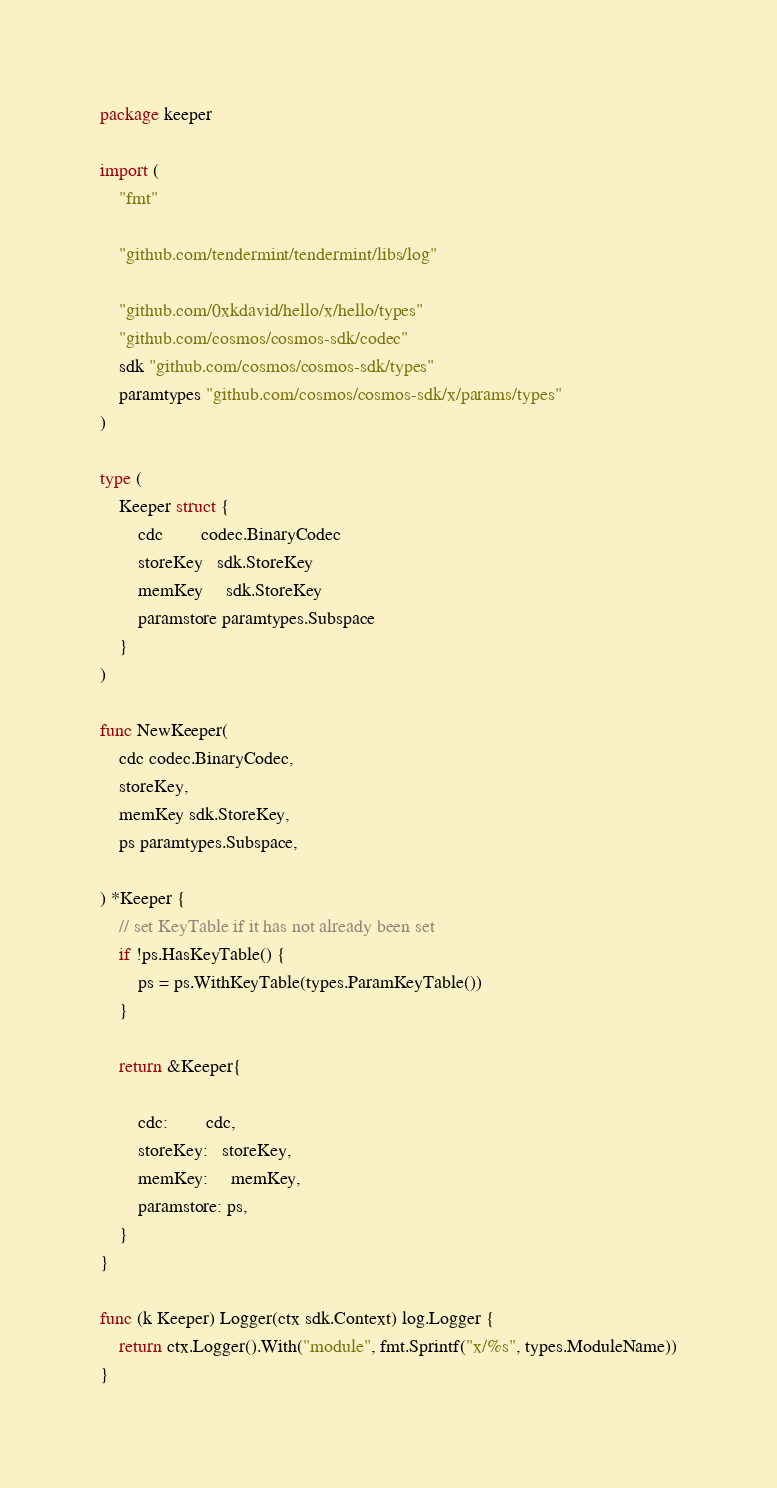Convert code to text. <code><loc_0><loc_0><loc_500><loc_500><_Go_>package keeper

import (
	"fmt"

	"github.com/tendermint/tendermint/libs/log"

	"github.com/0xkdavid/hello/x/hello/types"
	"github.com/cosmos/cosmos-sdk/codec"
	sdk "github.com/cosmos/cosmos-sdk/types"
	paramtypes "github.com/cosmos/cosmos-sdk/x/params/types"
)

type (
	Keeper struct {
		cdc        codec.BinaryCodec
		storeKey   sdk.StoreKey
		memKey     sdk.StoreKey
		paramstore paramtypes.Subspace
	}
)

func NewKeeper(
	cdc codec.BinaryCodec,
	storeKey,
	memKey sdk.StoreKey,
	ps paramtypes.Subspace,

) *Keeper {
	// set KeyTable if it has not already been set
	if !ps.HasKeyTable() {
		ps = ps.WithKeyTable(types.ParamKeyTable())
	}

	return &Keeper{

		cdc:        cdc,
		storeKey:   storeKey,
		memKey:     memKey,
		paramstore: ps,
	}
}

func (k Keeper) Logger(ctx sdk.Context) log.Logger {
	return ctx.Logger().With("module", fmt.Sprintf("x/%s", types.ModuleName))
}
</code> 